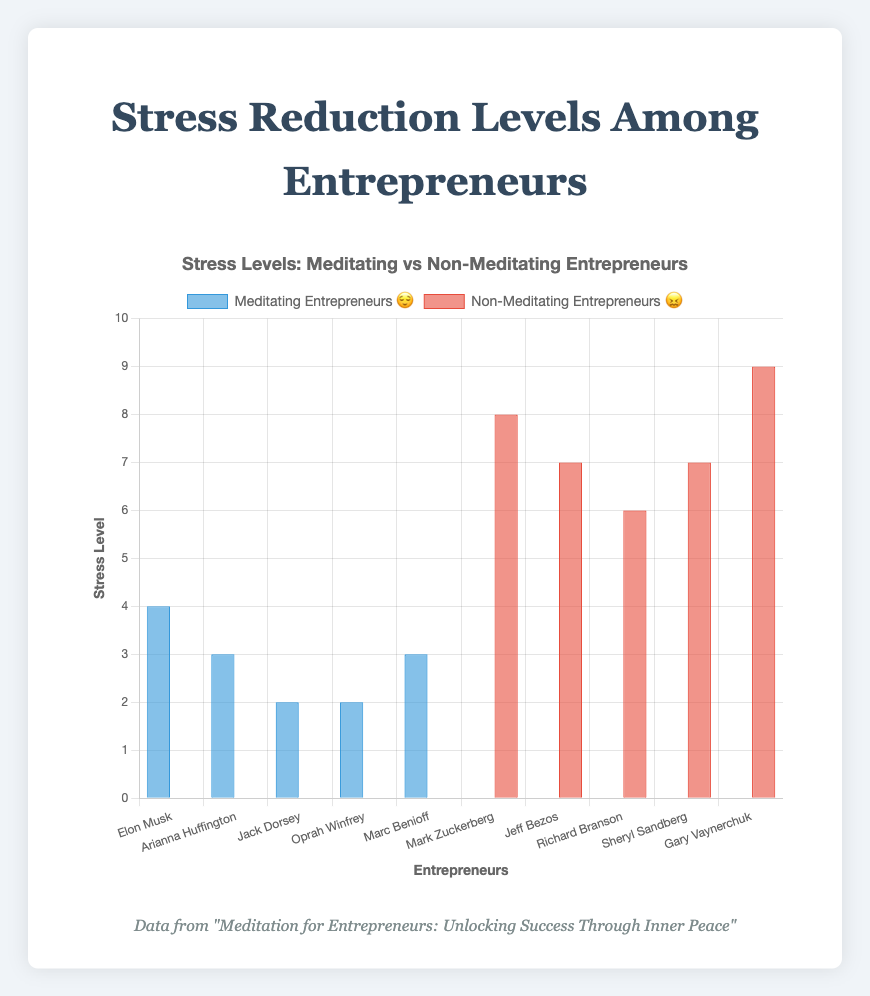What's the title of the chart? The title is usually displayed at the top of the chart. Here we are given that the title in the code is "Stress Levels: Meditating vs Non-Meditating Entrepreneurs".
Answer: Stress Levels: Meditating vs Non-Meditating Entrepreneurs What's the highest stress level among meditating entrepreneurs? 😌 To find this, look at the stress levels of Elon Musk (4), Arianna Huffington (3), Jack Dorsey (2), Oprah Winfrey (2), and Marc Benioff (3). The highest value is 4.
Answer: 4 What's the average stress level among non-meditating entrepreneurs? 😖 The stress levels given are Mark Zuckerberg (8), Jeff Bezos (7), Richard Branson (6), Sheryl Sandberg (7), and Gary Vaynerchuk (9). Sum these values (8 + 7 + 6 + 7 + 9 = 37) and divide by the number of entrepreneurs (5).
Answer: 7.4 Compare the lowest stress levels between meditating and non-meditating entrepreneurs. Which group has the lower level? The lowest stress level among meditating entrepreneurs is 2 (both Jack Dorsey and Oprah Winfrey), and among non-meditating entrepreneurs, it is 6 (Richard Branson). 2 is lower than 6.
Answer: Meditating Entrepreneurs 😌 How many entrepreneurs are in each group? The data indicates we have 5 meditating entrepreneurs and 5 non-meditating entrepreneurs.
Answer: 5 each What is the difference in average stress levels between the two groups? Calculate the average for meditating entrepreneurs: (4 + 3 + 2 + 2 + 3)/5 = 2.8. For non-meditating: 7.4 (previously calculated). Then, subtract the average of the meditating group from the non-meditating: 7.4 - 2.8 = 4.6.
Answer: 4.6 Which entrepreneur has the highest stress level overall? Look at both groups: non-meditating (Mark Zuckerberg 8, Jeff Bezos 7, Richard Branson 6, Sheryl Sandberg 7, Gary Vaynerchuk 9) and meditating (Elon Musk 4, Arianna Huffington 3, Jack Dorsey 2, Oprah Winfrey 2, Marc Benioff 3). The highest value is 9 (Gary Vaynerchuk).
Answer: Gary Vaynerchuk What's the sum of stress levels for meditating entrepreneurs? 😌 Add the stress levels of Elon Musk (4), Arianna Huffington (3), Jack Dorsey (2), Oprah Winfrey (2), and Marc Benioff (3): 4 + 3 + 2 + 2 + 3 = 14.
Answer: 14 Which group shows a higher variance in stress levels? Calculate the variance for each group. For meditating entrepreneurs: Mean is 2.8, variances are: (4-2.8)^2, (3-2.8)^2, (2-2.8)^2, (2-2.8)^2, (3-2.8)^2. Calculate these and sum them, then divide by 5. For non-meditating entrepreneurs: Mean is 7.4. Variances are: (8-7.4)^2, (7-7.4)^2, (6-7.4)^2, (7-7.4)^2, (9-7.4)^2, sum and divide by 5. Non-meditating entrepreneurs have higher variance.
Answer: Non-Meditating Entrepreneurs 😖 